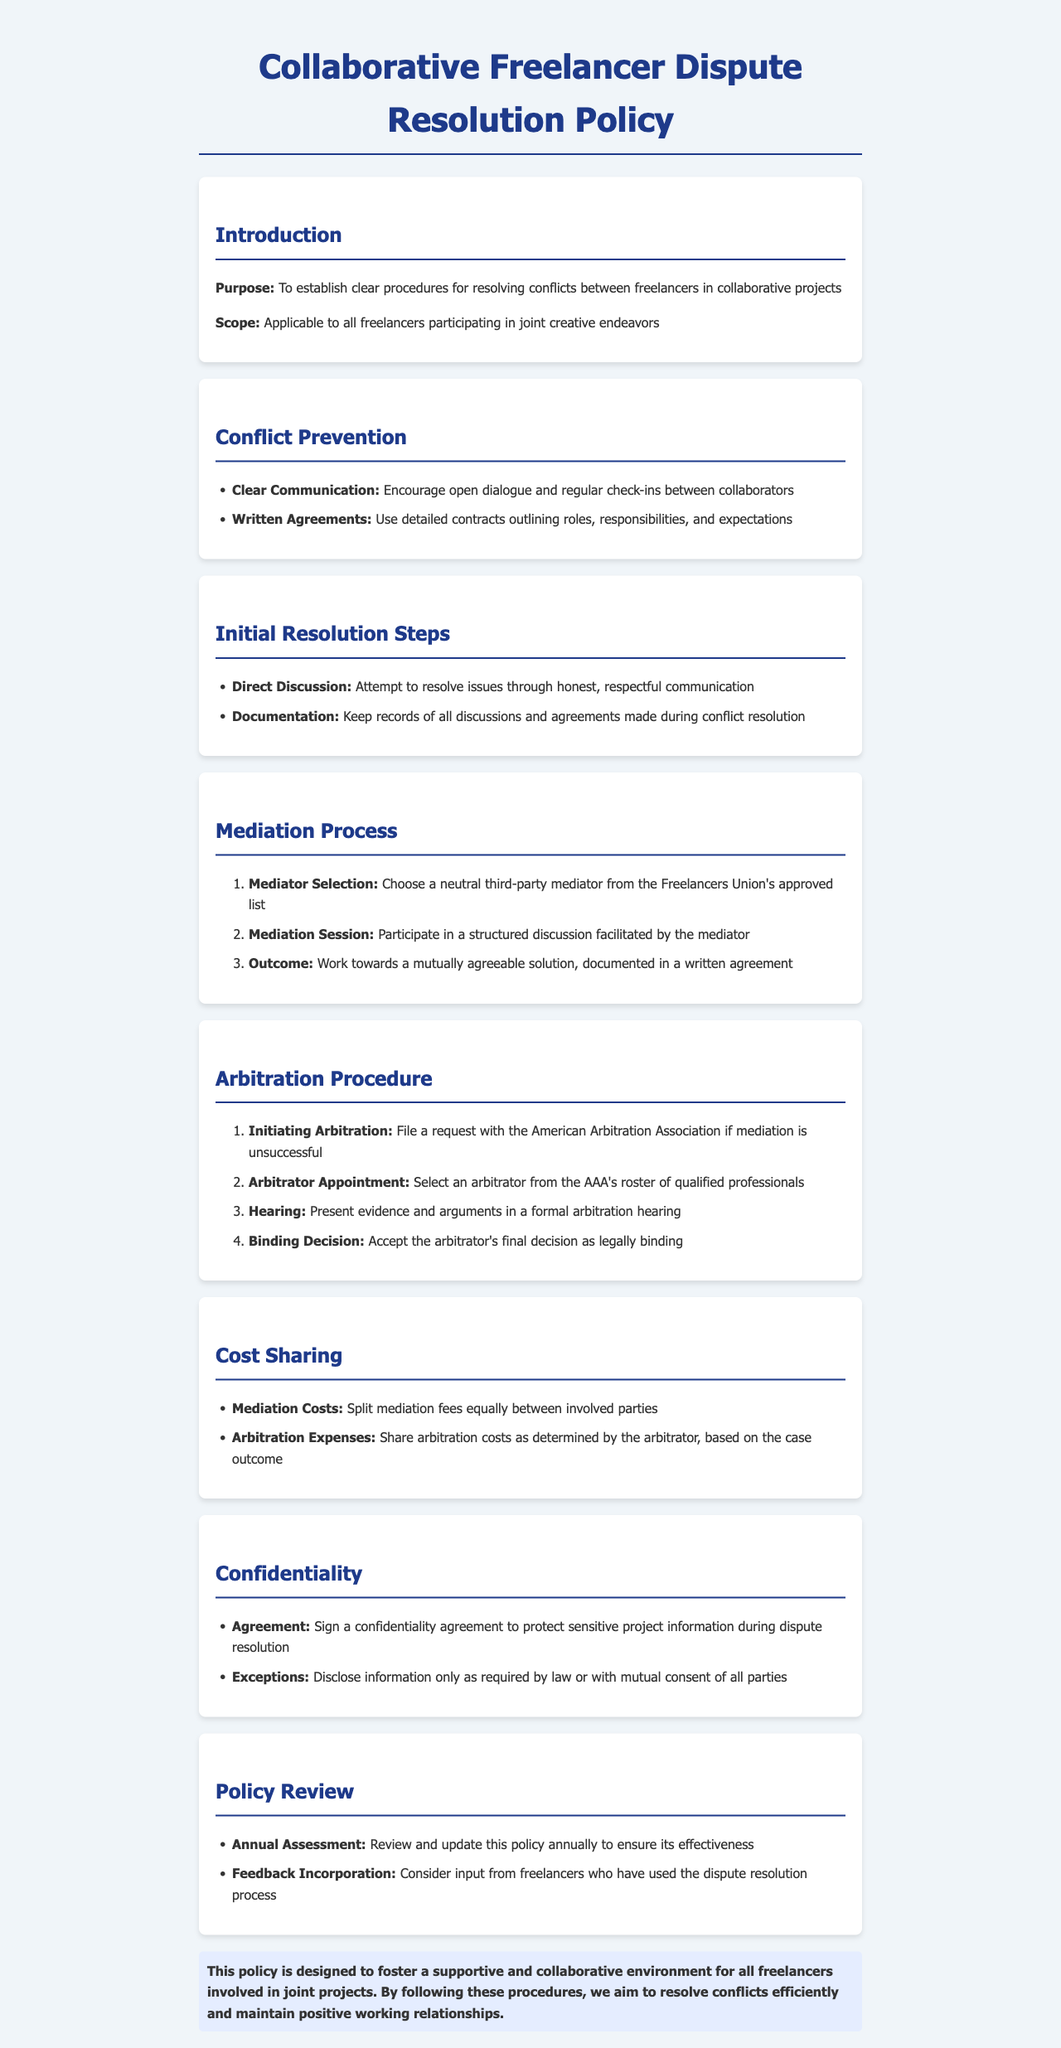What is the purpose of the policy? The purpose is to establish clear procedures for resolving conflicts between freelancers in collaborative projects.
Answer: Establish clear procedures for resolving conflicts between freelancers in collaborative projects Who is the scope of the policy applicable to? The scope applies to all freelancers participating in joint creative endeavors.
Answer: All freelancers participating in joint creative endeavors What is the first step in the initial resolution process? The first step is to attempt to resolve issues through honest, respectful communication.
Answer: Direct Discussion What should parties do if mediation is unsuccessful? If mediation fails, parties should file a request with the American Arbitration Association.
Answer: File a request with the American Arbitration Association How are mediation costs shared? Mediation costs are split equally between involved parties.
Answer: Split equally between involved parties What is required to protect sensitive project information during dispute resolution? Sign a confidentiality agreement to protect sensitive project information.
Answer: Sign a confidentiality agreement How often should the policy be reviewed? The policy should be reviewed annually.
Answer: Annually What is the desired outcome of the mediation session? The desired outcome is to work towards a mutually agreeable solution, documented in a written agreement.
Answer: A mutually agreeable solution, documented in a written agreement 